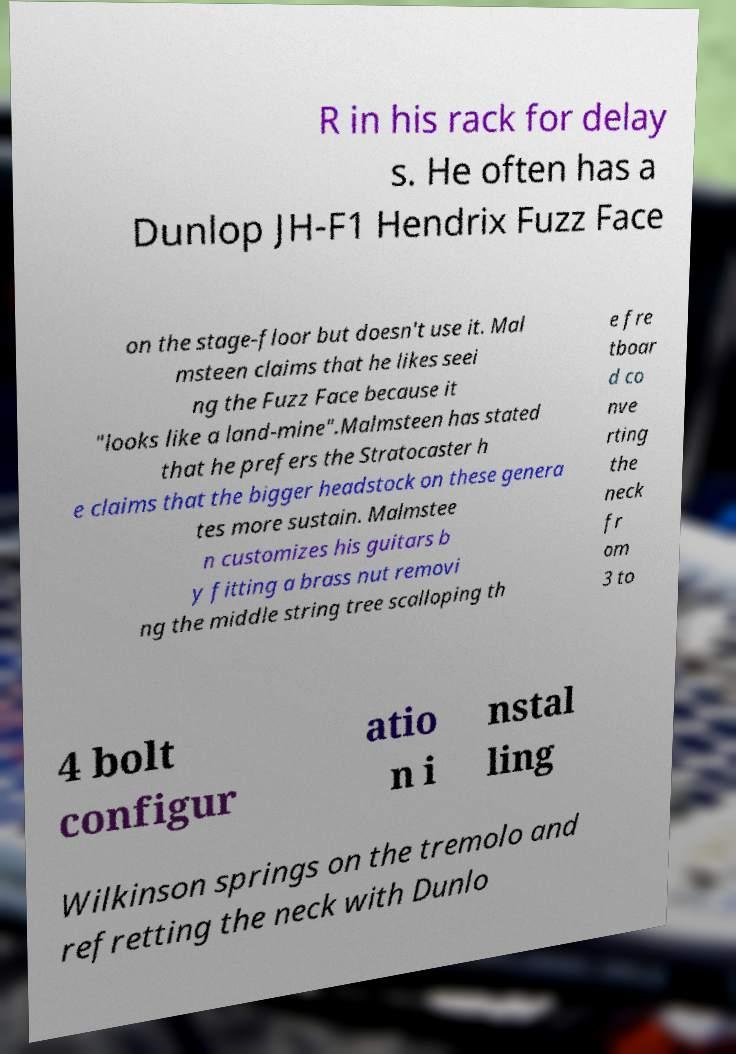For documentation purposes, I need the text within this image transcribed. Could you provide that? R in his rack for delay s. He often has a Dunlop JH-F1 Hendrix Fuzz Face on the stage-floor but doesn't use it. Mal msteen claims that he likes seei ng the Fuzz Face because it "looks like a land-mine".Malmsteen has stated that he prefers the Stratocaster h e claims that the bigger headstock on these genera tes more sustain. Malmstee n customizes his guitars b y fitting a brass nut removi ng the middle string tree scalloping th e fre tboar d co nve rting the neck fr om 3 to 4 bolt configur atio n i nstal ling Wilkinson springs on the tremolo and refretting the neck with Dunlo 